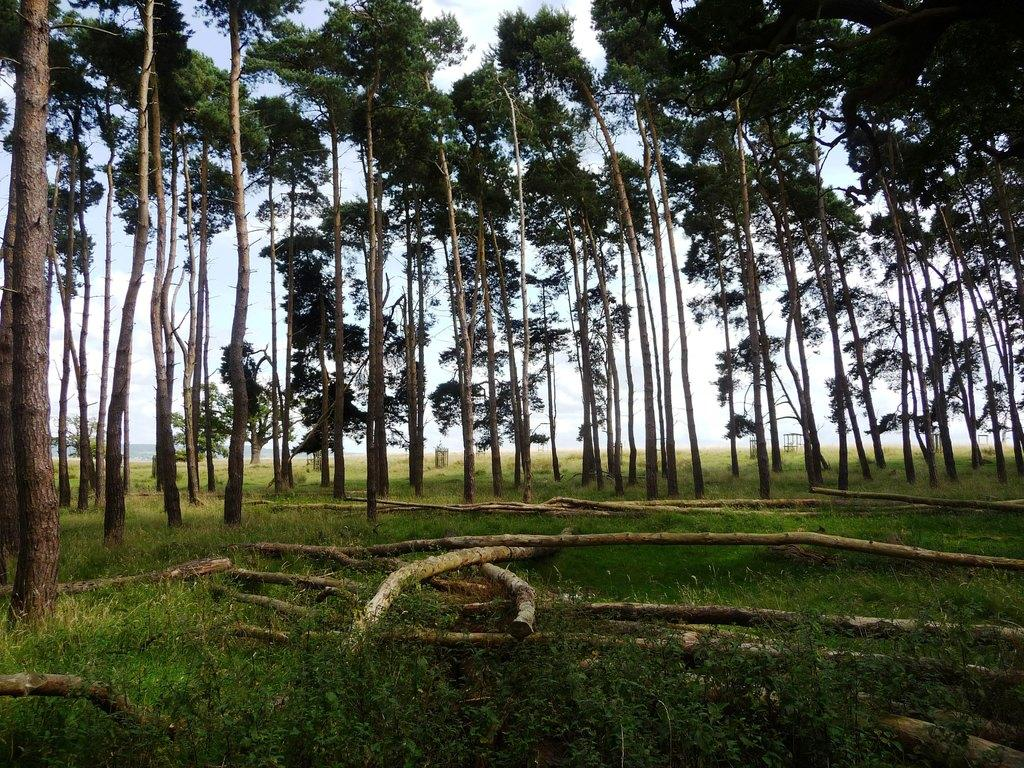What type of vegetation can be seen in the image? There are trees and grass in the image. What material are the barks made of in the image? The barks in the image are made of wood. What type of steel structure can be seen in the image? There is no steel structure present in the image; it features trees, wooden barks, and grass. Who is the friend in the image? There is no person or friend present in the image. 